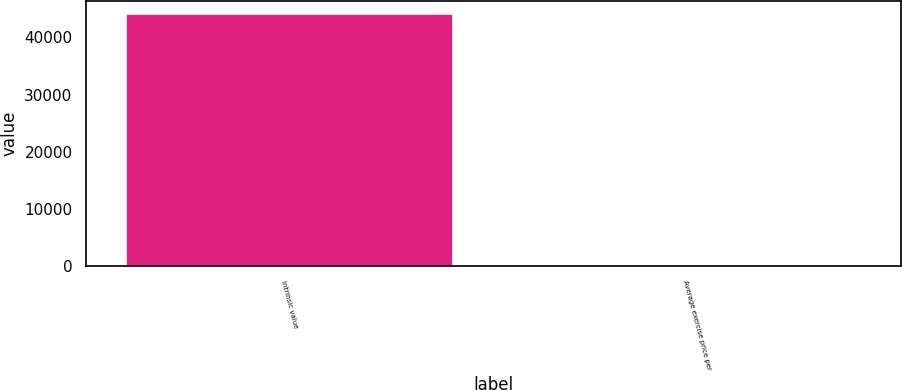Convert chart to OTSL. <chart><loc_0><loc_0><loc_500><loc_500><bar_chart><fcel>Intrinsic value<fcel>Average exercise price per<nl><fcel>44104<fcel>26.06<nl></chart> 